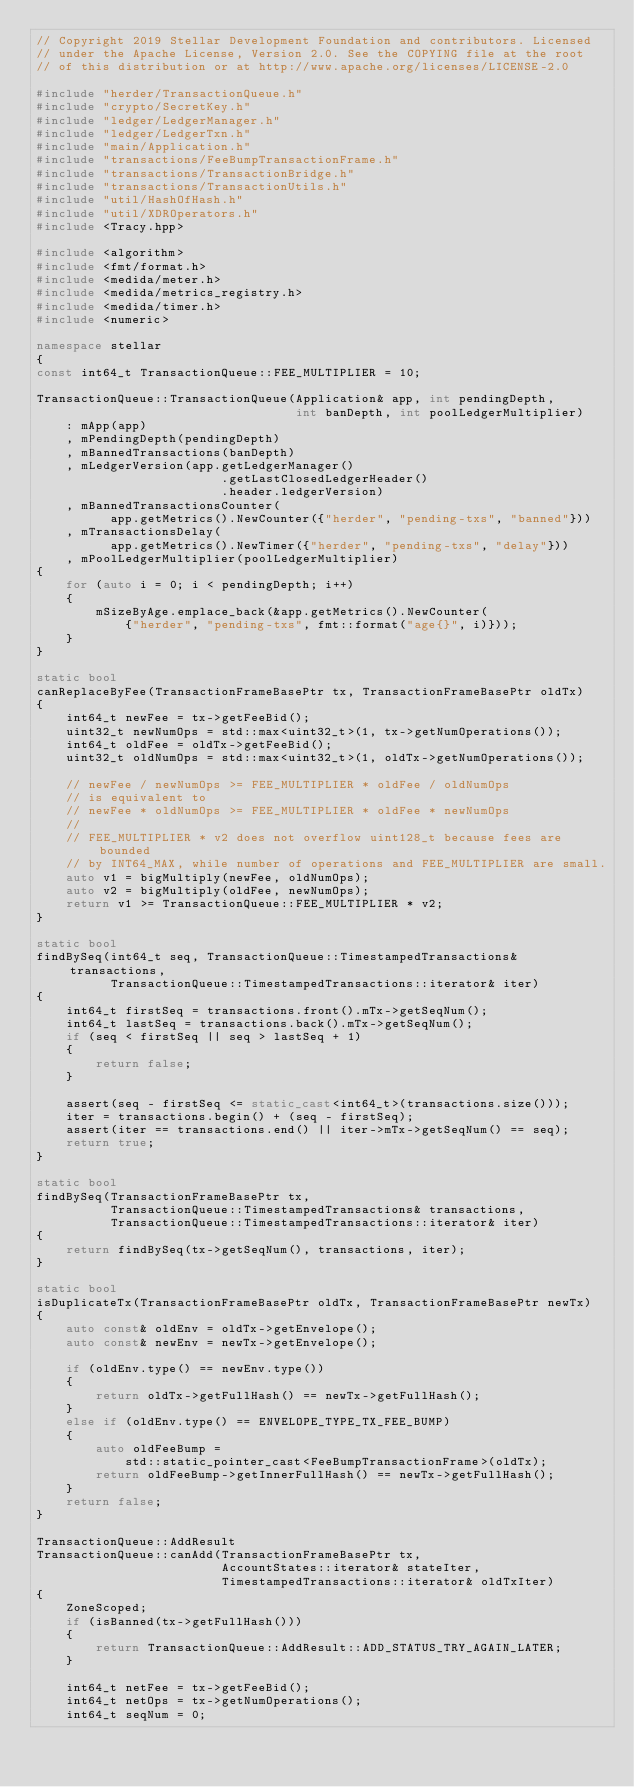Convert code to text. <code><loc_0><loc_0><loc_500><loc_500><_C++_>// Copyright 2019 Stellar Development Foundation and contributors. Licensed
// under the Apache License, Version 2.0. See the COPYING file at the root
// of this distribution or at http://www.apache.org/licenses/LICENSE-2.0

#include "herder/TransactionQueue.h"
#include "crypto/SecretKey.h"
#include "ledger/LedgerManager.h"
#include "ledger/LedgerTxn.h"
#include "main/Application.h"
#include "transactions/FeeBumpTransactionFrame.h"
#include "transactions/TransactionBridge.h"
#include "transactions/TransactionUtils.h"
#include "util/HashOfHash.h"
#include "util/XDROperators.h"
#include <Tracy.hpp>

#include <algorithm>
#include <fmt/format.h>
#include <medida/meter.h>
#include <medida/metrics_registry.h>
#include <medida/timer.h>
#include <numeric>

namespace stellar
{
const int64_t TransactionQueue::FEE_MULTIPLIER = 10;

TransactionQueue::TransactionQueue(Application& app, int pendingDepth,
                                   int banDepth, int poolLedgerMultiplier)
    : mApp(app)
    , mPendingDepth(pendingDepth)
    , mBannedTransactions(banDepth)
    , mLedgerVersion(app.getLedgerManager()
                         .getLastClosedLedgerHeader()
                         .header.ledgerVersion)
    , mBannedTransactionsCounter(
          app.getMetrics().NewCounter({"herder", "pending-txs", "banned"}))
    , mTransactionsDelay(
          app.getMetrics().NewTimer({"herder", "pending-txs", "delay"}))
    , mPoolLedgerMultiplier(poolLedgerMultiplier)
{
    for (auto i = 0; i < pendingDepth; i++)
    {
        mSizeByAge.emplace_back(&app.getMetrics().NewCounter(
            {"herder", "pending-txs", fmt::format("age{}", i)}));
    }
}

static bool
canReplaceByFee(TransactionFrameBasePtr tx, TransactionFrameBasePtr oldTx)
{
    int64_t newFee = tx->getFeeBid();
    uint32_t newNumOps = std::max<uint32_t>(1, tx->getNumOperations());
    int64_t oldFee = oldTx->getFeeBid();
    uint32_t oldNumOps = std::max<uint32_t>(1, oldTx->getNumOperations());

    // newFee / newNumOps >= FEE_MULTIPLIER * oldFee / oldNumOps
    // is equivalent to
    // newFee * oldNumOps >= FEE_MULTIPLIER * oldFee * newNumOps
    //
    // FEE_MULTIPLIER * v2 does not overflow uint128_t because fees are bounded
    // by INT64_MAX, while number of operations and FEE_MULTIPLIER are small.
    auto v1 = bigMultiply(newFee, oldNumOps);
    auto v2 = bigMultiply(oldFee, newNumOps);
    return v1 >= TransactionQueue::FEE_MULTIPLIER * v2;
}

static bool
findBySeq(int64_t seq, TransactionQueue::TimestampedTransactions& transactions,
          TransactionQueue::TimestampedTransactions::iterator& iter)
{
    int64_t firstSeq = transactions.front().mTx->getSeqNum();
    int64_t lastSeq = transactions.back().mTx->getSeqNum();
    if (seq < firstSeq || seq > lastSeq + 1)
    {
        return false;
    }

    assert(seq - firstSeq <= static_cast<int64_t>(transactions.size()));
    iter = transactions.begin() + (seq - firstSeq);
    assert(iter == transactions.end() || iter->mTx->getSeqNum() == seq);
    return true;
}

static bool
findBySeq(TransactionFrameBasePtr tx,
          TransactionQueue::TimestampedTransactions& transactions,
          TransactionQueue::TimestampedTransactions::iterator& iter)
{
    return findBySeq(tx->getSeqNum(), transactions, iter);
}

static bool
isDuplicateTx(TransactionFrameBasePtr oldTx, TransactionFrameBasePtr newTx)
{
    auto const& oldEnv = oldTx->getEnvelope();
    auto const& newEnv = newTx->getEnvelope();

    if (oldEnv.type() == newEnv.type())
    {
        return oldTx->getFullHash() == newTx->getFullHash();
    }
    else if (oldEnv.type() == ENVELOPE_TYPE_TX_FEE_BUMP)
    {
        auto oldFeeBump =
            std::static_pointer_cast<FeeBumpTransactionFrame>(oldTx);
        return oldFeeBump->getInnerFullHash() == newTx->getFullHash();
    }
    return false;
}

TransactionQueue::AddResult
TransactionQueue::canAdd(TransactionFrameBasePtr tx,
                         AccountStates::iterator& stateIter,
                         TimestampedTransactions::iterator& oldTxIter)
{
    ZoneScoped;
    if (isBanned(tx->getFullHash()))
    {
        return TransactionQueue::AddResult::ADD_STATUS_TRY_AGAIN_LATER;
    }

    int64_t netFee = tx->getFeeBid();
    int64_t netOps = tx->getNumOperations();
    int64_t seqNum = 0;
</code> 